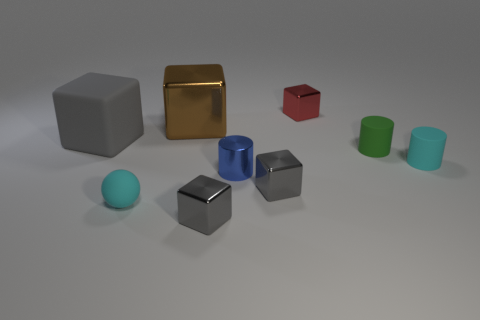Subtract all cyan cylinders. How many gray blocks are left? 3 Add 1 brown metallic things. How many objects exist? 10 Subtract all big shiny cubes. How many cubes are left? 4 Subtract 1 cubes. How many cubes are left? 4 Subtract all brown cubes. How many cubes are left? 4 Subtract all cylinders. How many objects are left? 6 Subtract all yellow blocks. Subtract all yellow balls. How many blocks are left? 5 Add 3 small gray metallic things. How many small gray metallic things exist? 5 Subtract 0 yellow balls. How many objects are left? 9 Subtract all small gray shiny things. Subtract all large brown objects. How many objects are left? 6 